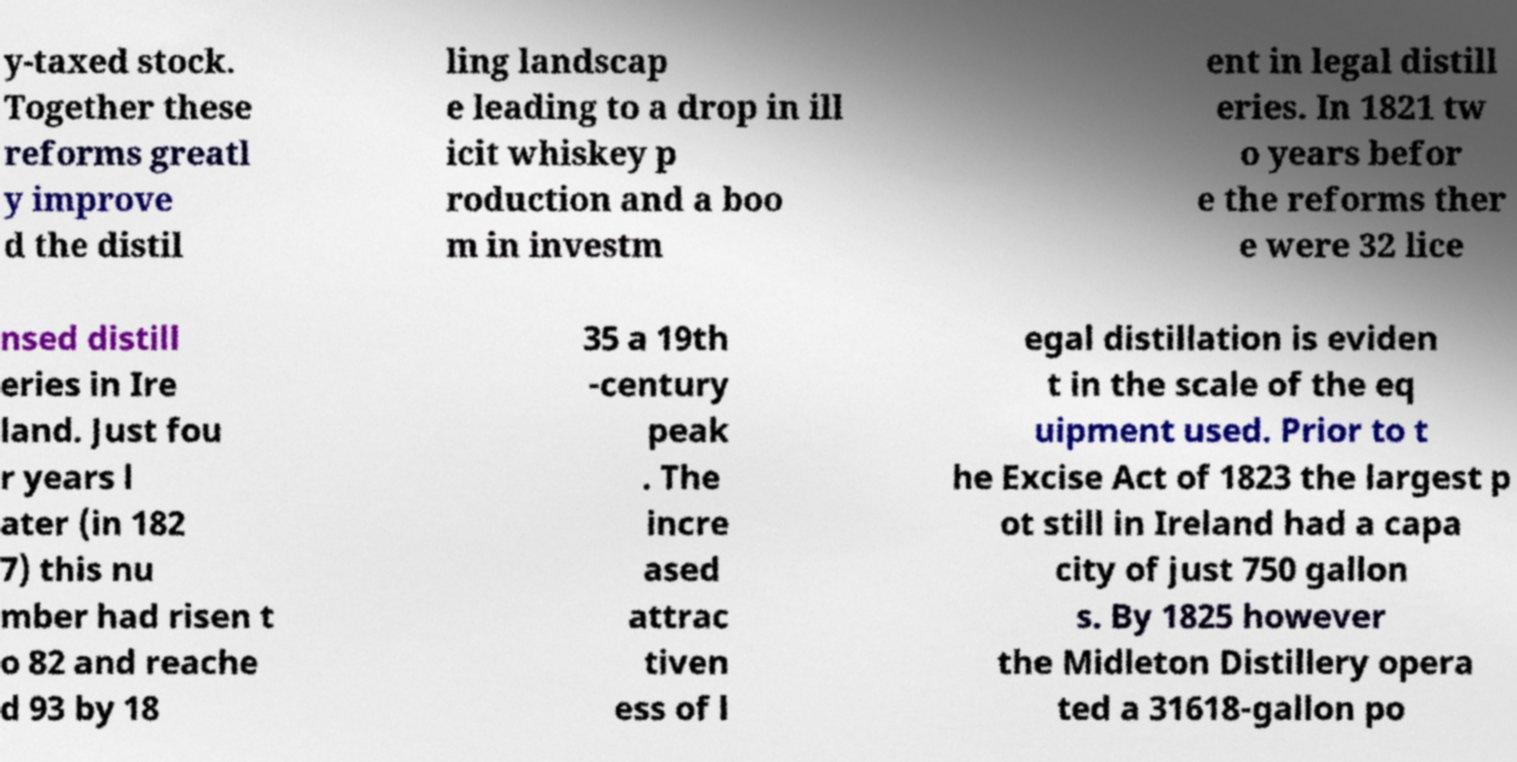Please identify and transcribe the text found in this image. y-taxed stock. Together these reforms greatl y improve d the distil ling landscap e leading to a drop in ill icit whiskey p roduction and a boo m in investm ent in legal distill eries. In 1821 tw o years befor e the reforms ther e were 32 lice nsed distill eries in Ire land. Just fou r years l ater (in 182 7) this nu mber had risen t o 82 and reache d 93 by 18 35 a 19th -century peak . The incre ased attrac tiven ess of l egal distillation is eviden t in the scale of the eq uipment used. Prior to t he Excise Act of 1823 the largest p ot still in Ireland had a capa city of just 750 gallon s. By 1825 however the Midleton Distillery opera ted a 31618-gallon po 